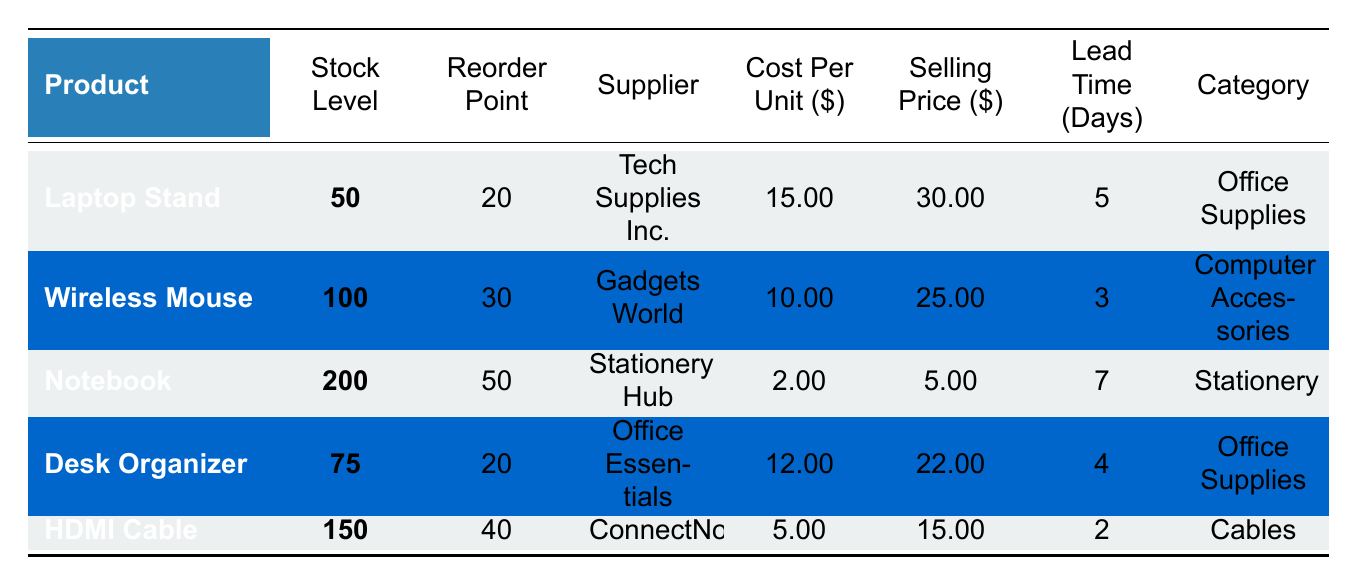What is the stock level of the Wireless Mouse? The stock level for the Wireless Mouse is explicitly stated in the table. It is shown as 100.
Answer: 100 Which product has the highest selling price? By examining the selling prices listed for each product, the Notebook has the highest selling price at $5.00, but the highest among the other items is the Laptop Stand at $30.00.
Answer: Laptop Stand True or false: The Lead Time for HDMI Cable is more than 3 days. In the table, the Lead Time for HDMI Cable is listed as 2 days, which is less than 3 days.
Answer: False What is the total cost of stocking the Desk Organizer? To calculate the total cost of the Desk Organizer, multiply the stock level (75) by the cost per unit ($12.00): 75 * 12 = 900.
Answer: 900 What product category has the lowest reorder point? By comparing the reorder points, the Laptop Stand and Desk Organizer both have a reorder point of 20, which is the lowest among all categories listed.
Answer: Office Supplies How much profit can be made from selling one unit of Notebook? The profit from one unit is calculated by subtracting the cost per unit ($2.00) from the selling price ($5.00): 5 - 2 = 3.
Answer: 3 What is the average lead time for all products in the table? To find the average lead time, add all lead times (5 + 3 + 7 + 4 + 2) = 21, and divide by the number of products (5): 21 / 5 = 4.2.
Answer: 4.2 If the stock level of HDMI Cable drops to its reorder point, how many more units need to be ordered? The stock level of HDMI Cable is currently 150 and the reorder point is 40. If it drops to 40, no additional units need to be ordered since the current level is above the reorder point.
Answer: 0 Which product has the longest lead time? The lead times for each product are compared, with the Notebook having the longest lead time of 7 days.
Answer: Notebook What is the total stock for all office supplies? The total stock for Office Supplies includes the Laptop Stand (50) and Desk Organizer (75). The sum is 50 + 75 = 125.
Answer: 125 